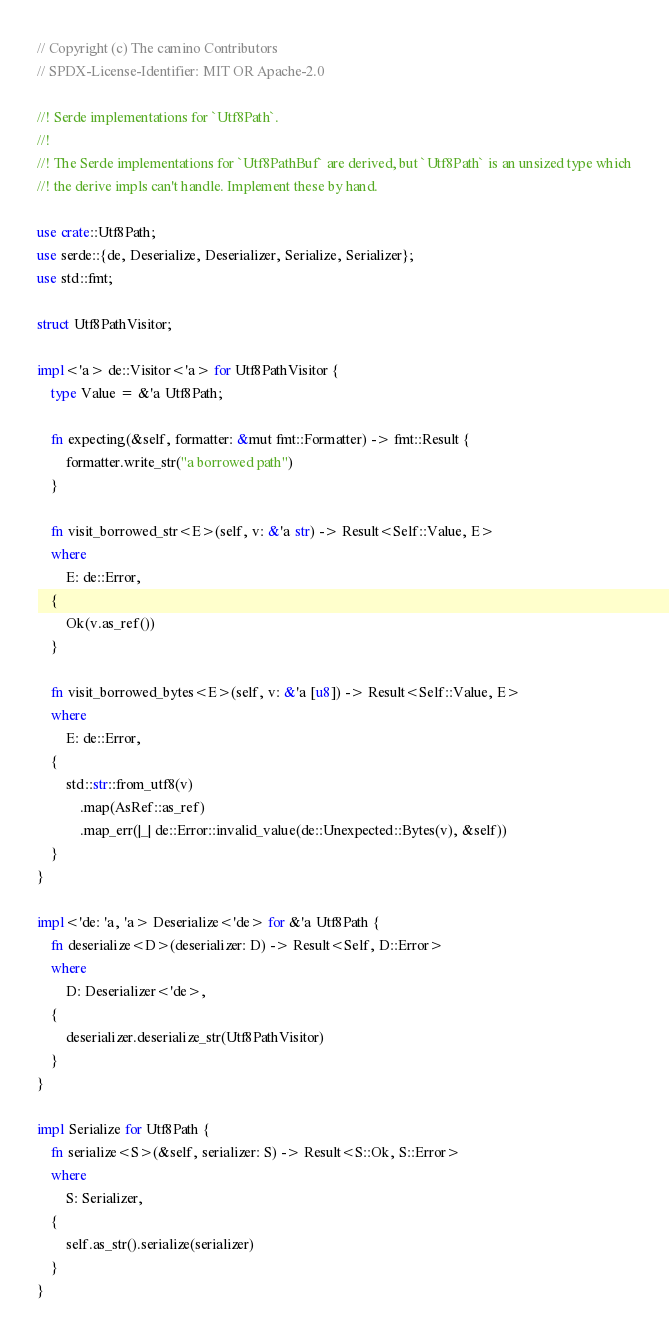<code> <loc_0><loc_0><loc_500><loc_500><_Rust_>// Copyright (c) The camino Contributors
// SPDX-License-Identifier: MIT OR Apache-2.0

//! Serde implementations for `Utf8Path`.
//!
//! The Serde implementations for `Utf8PathBuf` are derived, but `Utf8Path` is an unsized type which
//! the derive impls can't handle. Implement these by hand.

use crate::Utf8Path;
use serde::{de, Deserialize, Deserializer, Serialize, Serializer};
use std::fmt;

struct Utf8PathVisitor;

impl<'a> de::Visitor<'a> for Utf8PathVisitor {
    type Value = &'a Utf8Path;

    fn expecting(&self, formatter: &mut fmt::Formatter) -> fmt::Result {
        formatter.write_str("a borrowed path")
    }

    fn visit_borrowed_str<E>(self, v: &'a str) -> Result<Self::Value, E>
    where
        E: de::Error,
    {
        Ok(v.as_ref())
    }

    fn visit_borrowed_bytes<E>(self, v: &'a [u8]) -> Result<Self::Value, E>
    where
        E: de::Error,
    {
        std::str::from_utf8(v)
            .map(AsRef::as_ref)
            .map_err(|_| de::Error::invalid_value(de::Unexpected::Bytes(v), &self))
    }
}

impl<'de: 'a, 'a> Deserialize<'de> for &'a Utf8Path {
    fn deserialize<D>(deserializer: D) -> Result<Self, D::Error>
    where
        D: Deserializer<'de>,
    {
        deserializer.deserialize_str(Utf8PathVisitor)
    }
}

impl Serialize for Utf8Path {
    fn serialize<S>(&self, serializer: S) -> Result<S::Ok, S::Error>
    where
        S: Serializer,
    {
        self.as_str().serialize(serializer)
    }
}
</code> 